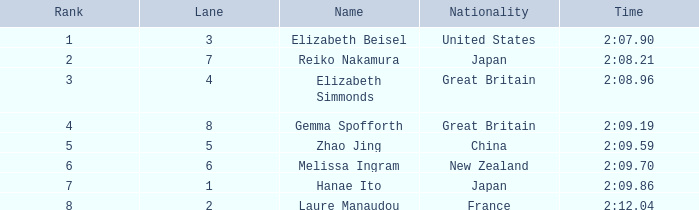What is Elizabeth Simmonds' average lane number? 4.0. Would you be able to parse every entry in this table? {'header': ['Rank', 'Lane', 'Name', 'Nationality', 'Time'], 'rows': [['1', '3', 'Elizabeth Beisel', 'United States', '2:07.90'], ['2', '7', 'Reiko Nakamura', 'Japan', '2:08.21'], ['3', '4', 'Elizabeth Simmonds', 'Great Britain', '2:08.96'], ['4', '8', 'Gemma Spofforth', 'Great Britain', '2:09.19'], ['5', '5', 'Zhao Jing', 'China', '2:09.59'], ['6', '6', 'Melissa Ingram', 'New Zealand', '2:09.70'], ['7', '1', 'Hanae Ito', 'Japan', '2:09.86'], ['8', '2', 'Laure Manaudou', 'France', '2:12.04']]} 